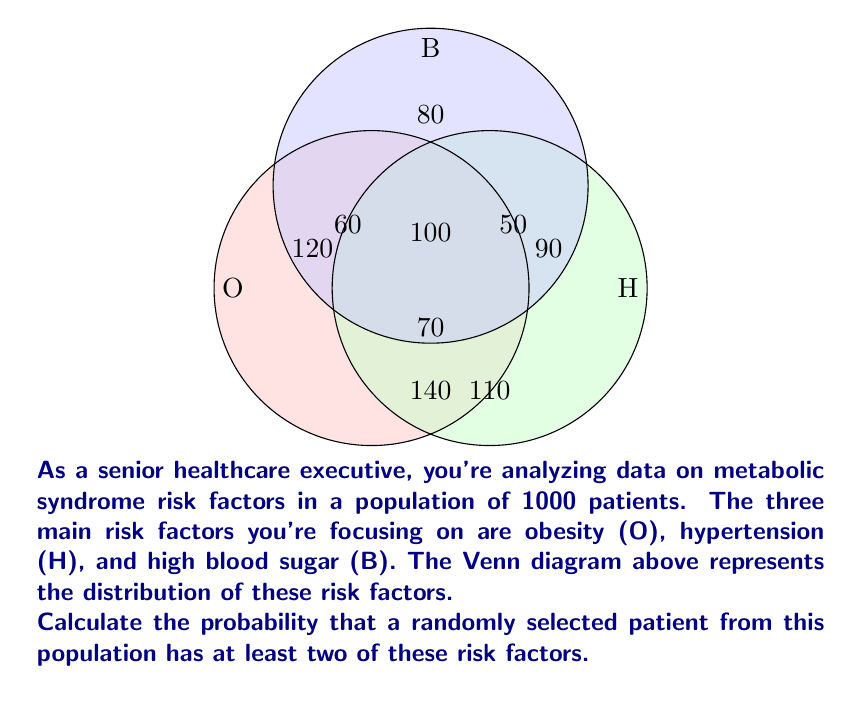What is the answer to this math problem? Let's approach this step-by-step:

1) First, we need to identify the number of patients with at least two risk factors. This includes:
   - Patients with all three risk factors (O ∩ H ∩ B): 100
   - Patients with only obesity and hypertension (O ∩ H): 60
   - Patients with only obesity and high blood sugar (O ∩ B): 70
   - Patients with only hypertension and high blood sugar (H ∩ B): 50

2) Let's sum these up:
   $100 + 60 + 70 + 50 = 280$ patients

3) To calculate the probability, we divide this number by the total population:

   $$P(\text{at least two risk factors}) = \frac{\text{number of patients with at least two risk factors}}{\text{total population}}$$

   $$P(\text{at least two risk factors}) = \frac{280}{1000} = 0.28$$

4) This can be expressed as a percentage:
   $0.28 \times 100\% = 28\%$

Therefore, the probability that a randomly selected patient has at least two of these risk factors is 0.28 or 28%.
Answer: 0.28 